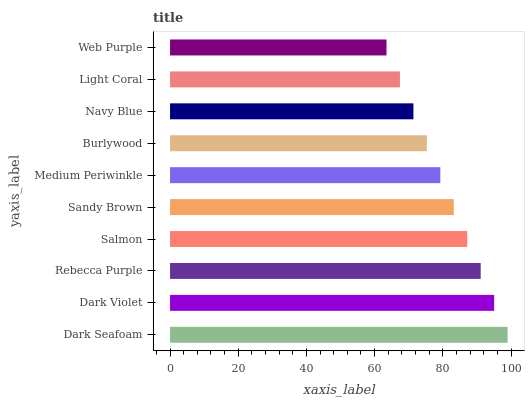Is Web Purple the minimum?
Answer yes or no. Yes. Is Dark Seafoam the maximum?
Answer yes or no. Yes. Is Dark Violet the minimum?
Answer yes or no. No. Is Dark Violet the maximum?
Answer yes or no. No. Is Dark Seafoam greater than Dark Violet?
Answer yes or no. Yes. Is Dark Violet less than Dark Seafoam?
Answer yes or no. Yes. Is Dark Violet greater than Dark Seafoam?
Answer yes or no. No. Is Dark Seafoam less than Dark Violet?
Answer yes or no. No. Is Sandy Brown the high median?
Answer yes or no. Yes. Is Medium Periwinkle the low median?
Answer yes or no. Yes. Is Navy Blue the high median?
Answer yes or no. No. Is Sandy Brown the low median?
Answer yes or no. No. 